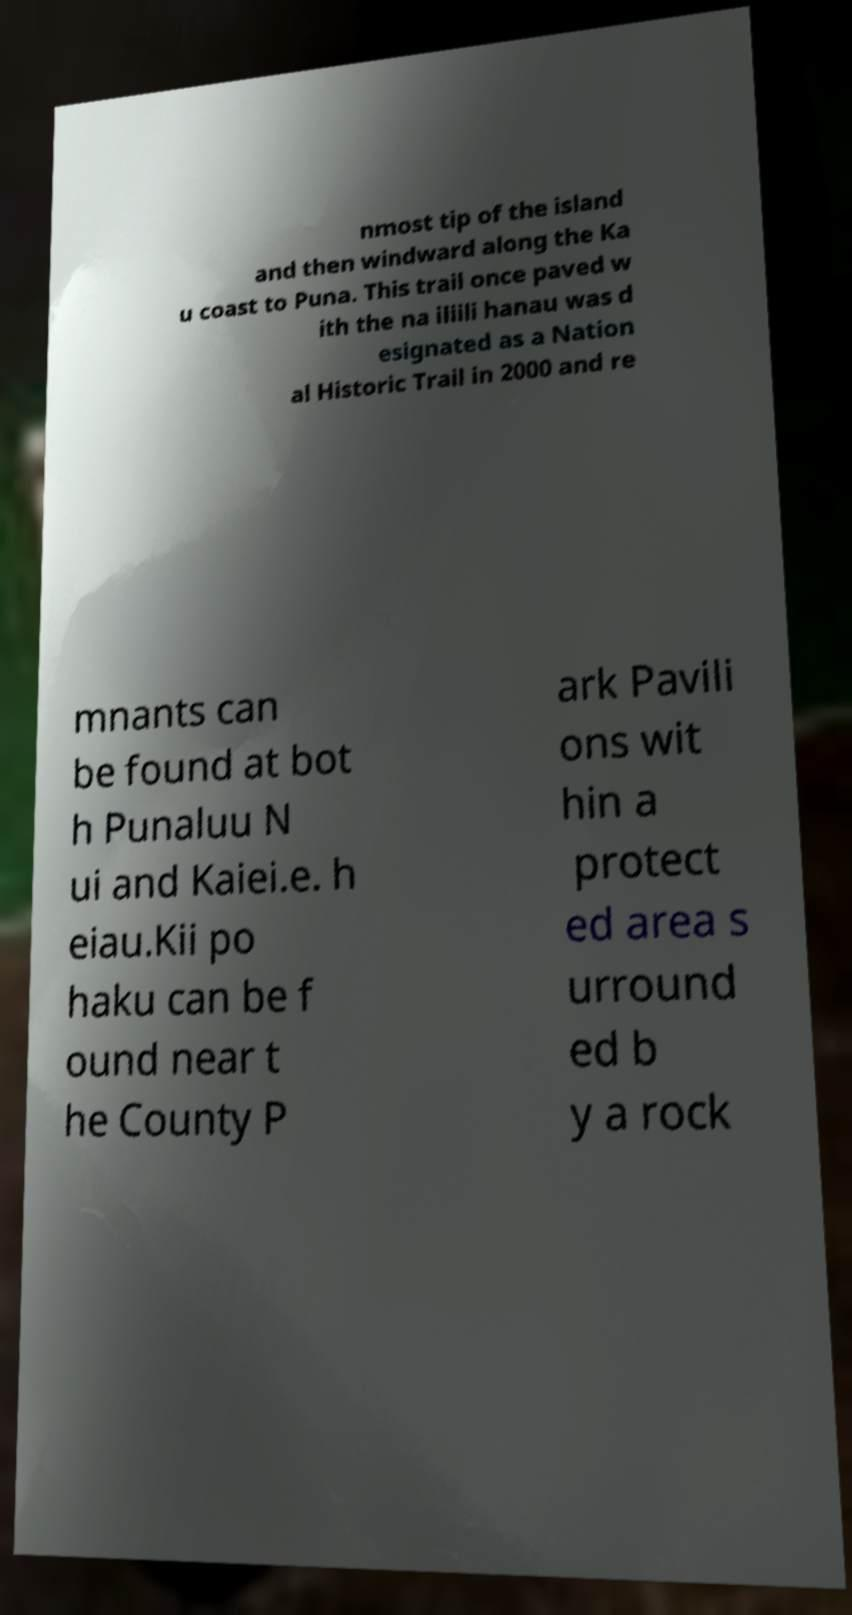Can you read and provide the text displayed in the image?This photo seems to have some interesting text. Can you extract and type it out for me? nmost tip of the island and then windward along the Ka u coast to Puna. This trail once paved w ith the na iliili hanau was d esignated as a Nation al Historic Trail in 2000 and re mnants can be found at bot h Punaluu N ui and Kaiei.e. h eiau.Kii po haku can be f ound near t he County P ark Pavili ons wit hin a protect ed area s urround ed b y a rock 